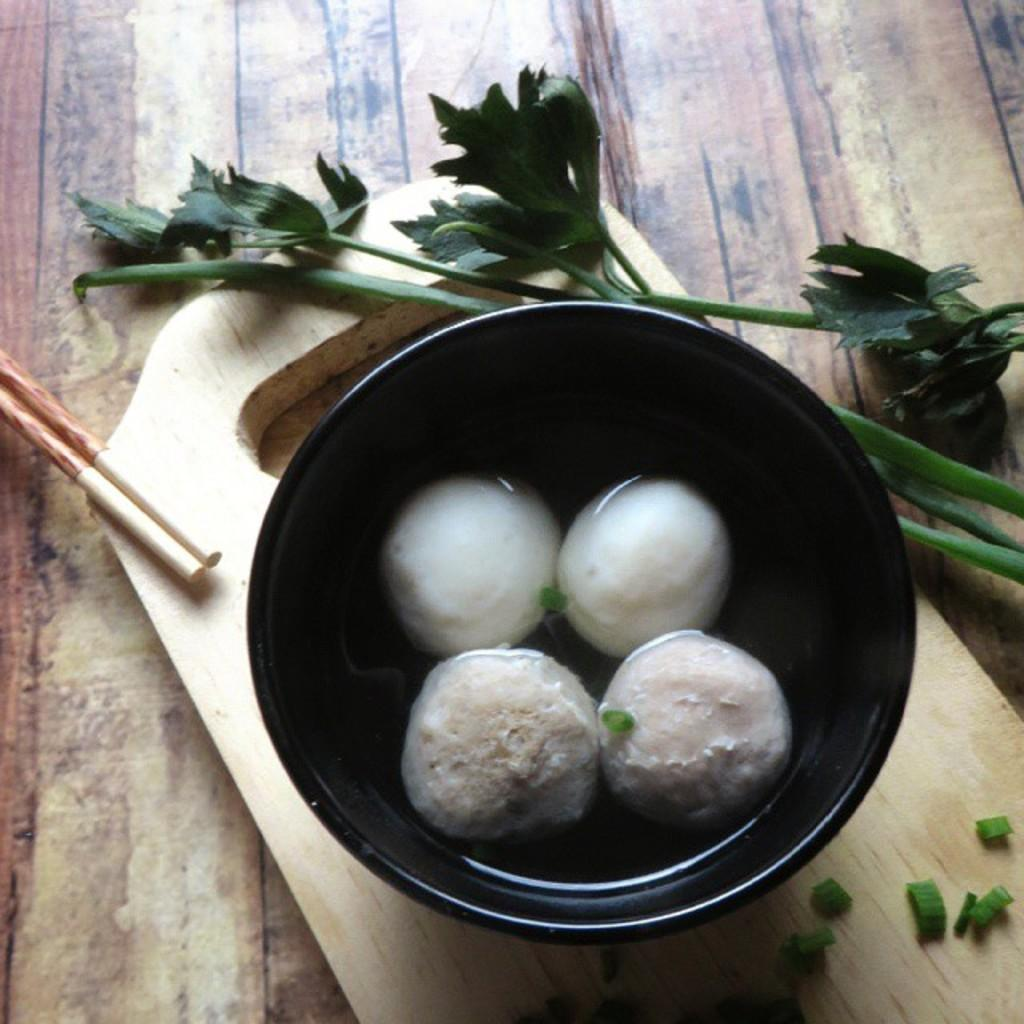What material is the table made of in the image? The table is made of wood. What is in the bowl on the table? There is a food item in the bowl on the table. What utensils are visible on the table? Chopsticks are visible on the table. What other item made of wood can be seen on the table? There is a wooden cutting board on the table. What type of food is present on the table? Leafy vegetables are present on the table. What type of weather can be seen in the image? The image does not depict any weather conditions, as it is focused on the table and its contents. 